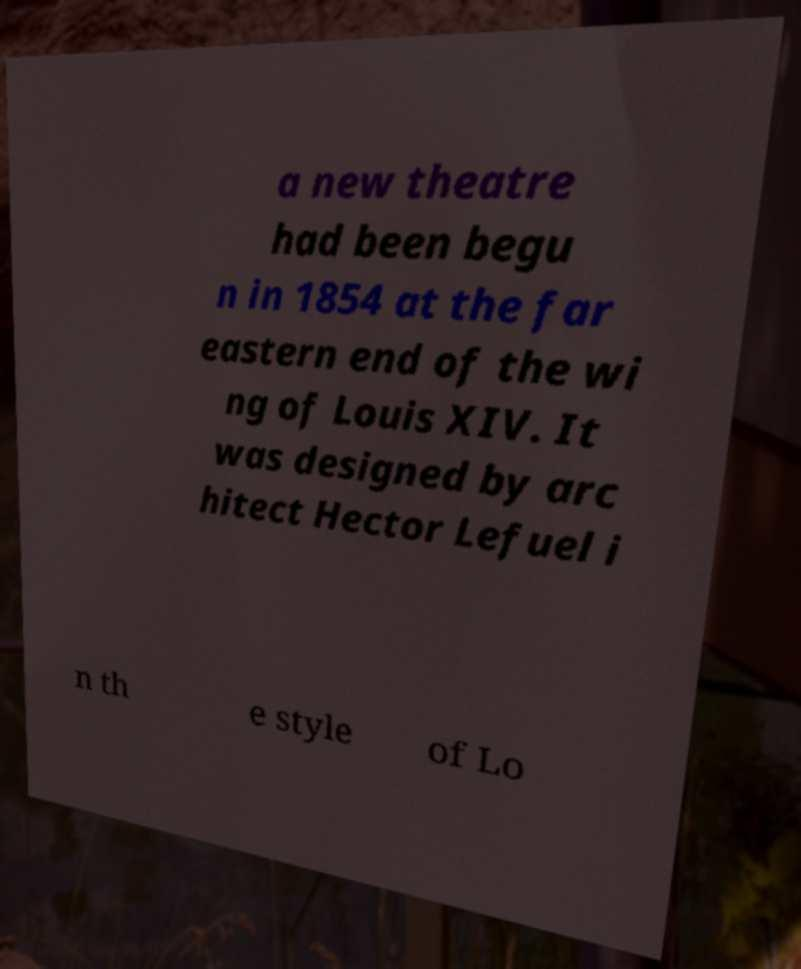I need the written content from this picture converted into text. Can you do that? a new theatre had been begu n in 1854 at the far eastern end of the wi ng of Louis XIV. It was designed by arc hitect Hector Lefuel i n th e style of Lo 